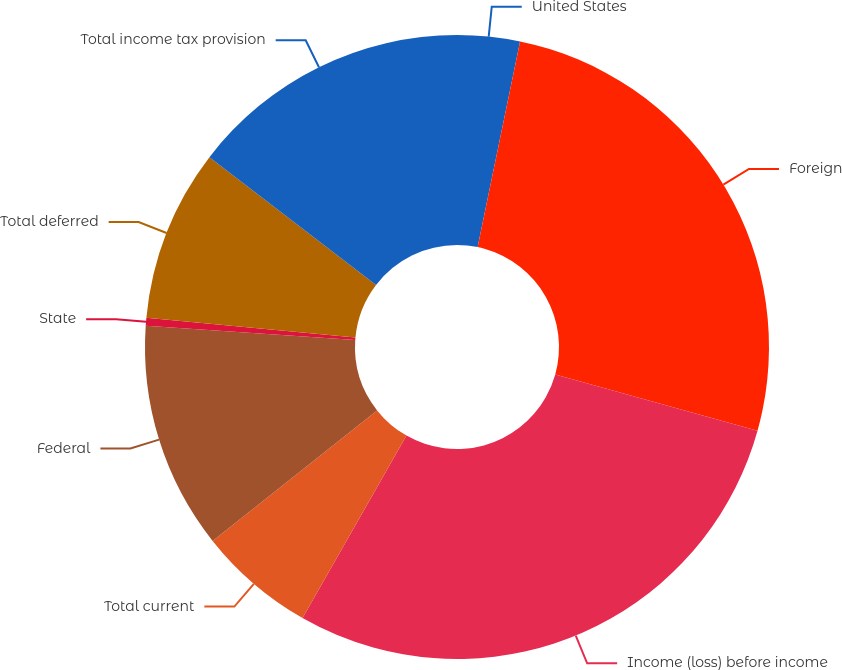<chart> <loc_0><loc_0><loc_500><loc_500><pie_chart><fcel>United States<fcel>Foreign<fcel>Income (loss) before income<fcel>Total current<fcel>Federal<fcel>State<fcel>Total deferred<fcel>Total income tax provision<nl><fcel>3.24%<fcel>26.09%<fcel>28.92%<fcel>6.08%<fcel>11.76%<fcel>0.41%<fcel>8.92%<fcel>14.59%<nl></chart> 